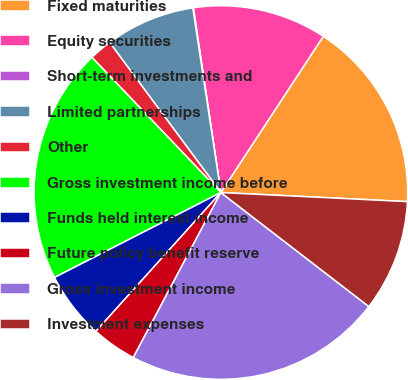Convert chart. <chart><loc_0><loc_0><loc_500><loc_500><pie_chart><fcel>Fixed maturities<fcel>Equity securities<fcel>Short-term investments and<fcel>Limited partnerships<fcel>Other<fcel>Gross investment income before<fcel>Funds held interest income<fcel>Future policy benefit reserve<fcel>Gross investment income<fcel>Investment expenses<nl><fcel>16.54%<fcel>11.59%<fcel>0.05%<fcel>7.75%<fcel>1.97%<fcel>20.39%<fcel>5.82%<fcel>3.9%<fcel>22.32%<fcel>9.67%<nl></chart> 